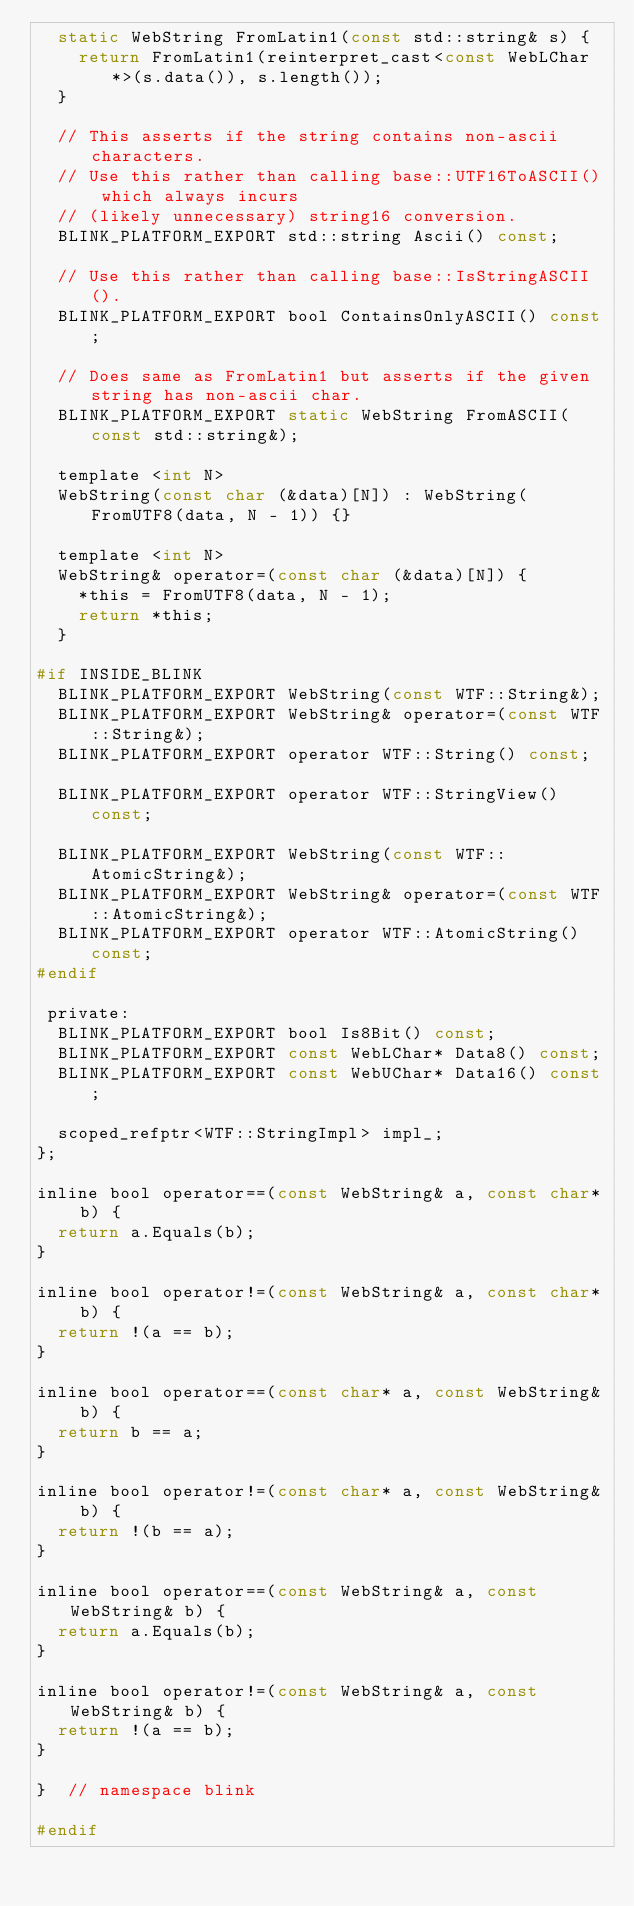<code> <loc_0><loc_0><loc_500><loc_500><_C_>  static WebString FromLatin1(const std::string& s) {
    return FromLatin1(reinterpret_cast<const WebLChar*>(s.data()), s.length());
  }

  // This asserts if the string contains non-ascii characters.
  // Use this rather than calling base::UTF16ToASCII() which always incurs
  // (likely unnecessary) string16 conversion.
  BLINK_PLATFORM_EXPORT std::string Ascii() const;

  // Use this rather than calling base::IsStringASCII().
  BLINK_PLATFORM_EXPORT bool ContainsOnlyASCII() const;

  // Does same as FromLatin1 but asserts if the given string has non-ascii char.
  BLINK_PLATFORM_EXPORT static WebString FromASCII(const std::string&);

  template <int N>
  WebString(const char (&data)[N]) : WebString(FromUTF8(data, N - 1)) {}

  template <int N>
  WebString& operator=(const char (&data)[N]) {
    *this = FromUTF8(data, N - 1);
    return *this;
  }

#if INSIDE_BLINK
  BLINK_PLATFORM_EXPORT WebString(const WTF::String&);
  BLINK_PLATFORM_EXPORT WebString& operator=(const WTF::String&);
  BLINK_PLATFORM_EXPORT operator WTF::String() const;

  BLINK_PLATFORM_EXPORT operator WTF::StringView() const;

  BLINK_PLATFORM_EXPORT WebString(const WTF::AtomicString&);
  BLINK_PLATFORM_EXPORT WebString& operator=(const WTF::AtomicString&);
  BLINK_PLATFORM_EXPORT operator WTF::AtomicString() const;
#endif

 private:
  BLINK_PLATFORM_EXPORT bool Is8Bit() const;
  BLINK_PLATFORM_EXPORT const WebLChar* Data8() const;
  BLINK_PLATFORM_EXPORT const WebUChar* Data16() const;

  scoped_refptr<WTF::StringImpl> impl_;
};

inline bool operator==(const WebString& a, const char* b) {
  return a.Equals(b);
}

inline bool operator!=(const WebString& a, const char* b) {
  return !(a == b);
}

inline bool operator==(const char* a, const WebString& b) {
  return b == a;
}

inline bool operator!=(const char* a, const WebString& b) {
  return !(b == a);
}

inline bool operator==(const WebString& a, const WebString& b) {
  return a.Equals(b);
}

inline bool operator!=(const WebString& a, const WebString& b) {
  return !(a == b);
}

}  // namespace blink

#endif
</code> 